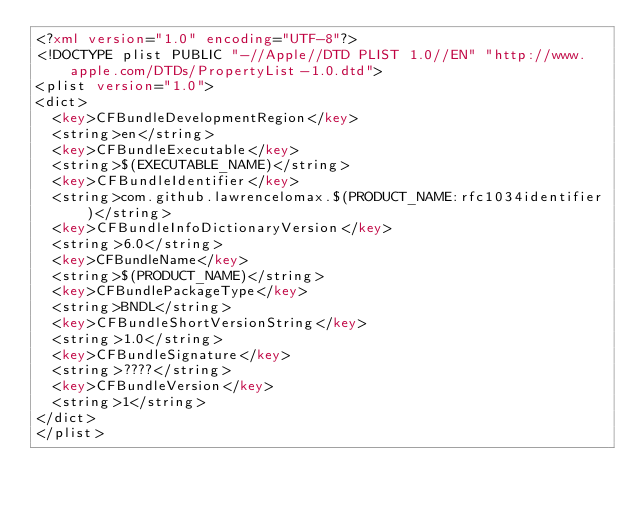<code> <loc_0><loc_0><loc_500><loc_500><_XML_><?xml version="1.0" encoding="UTF-8"?>
<!DOCTYPE plist PUBLIC "-//Apple//DTD PLIST 1.0//EN" "http://www.apple.com/DTDs/PropertyList-1.0.dtd">
<plist version="1.0">
<dict>
	<key>CFBundleDevelopmentRegion</key>
	<string>en</string>
	<key>CFBundleExecutable</key>
	<string>$(EXECUTABLE_NAME)</string>
	<key>CFBundleIdentifier</key>
	<string>com.github.lawrencelomax.$(PRODUCT_NAME:rfc1034identifier)</string>
	<key>CFBundleInfoDictionaryVersion</key>
	<string>6.0</string>
	<key>CFBundleName</key>
	<string>$(PRODUCT_NAME)</string>
	<key>CFBundlePackageType</key>
	<string>BNDL</string>
	<key>CFBundleShortVersionString</key>
	<string>1.0</string>
	<key>CFBundleSignature</key>
	<string>????</string>
	<key>CFBundleVersion</key>
	<string>1</string>
</dict>
</plist>
</code> 